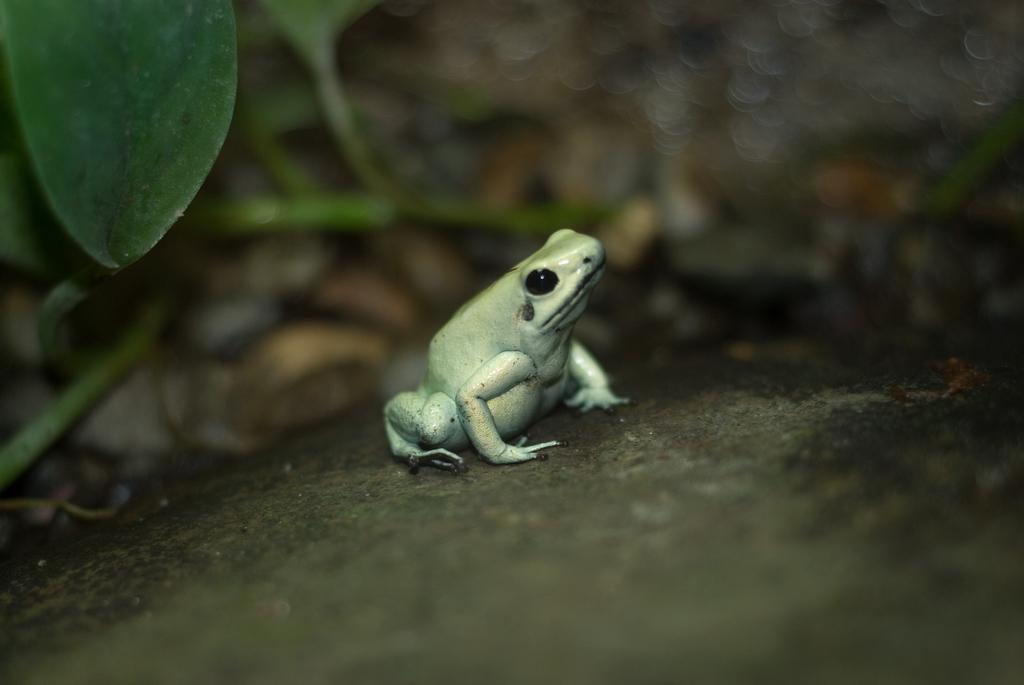What animal is present in the image? There is a frog in the image. What color is the frog? The frog is green in color. Where is the frog located? The frog is on a rock. What can be seen in the background of the image? There are leaves in the background of the image. What color are the leaves? The leaves are green in color. Is the girl teaching the frog how to jump in the image? There is no girl present in the image, and therefore no teaching or jumping can be observed. 